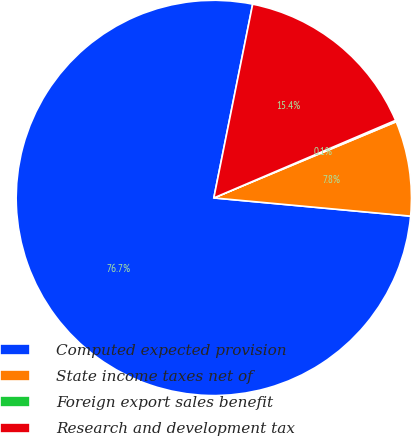<chart> <loc_0><loc_0><loc_500><loc_500><pie_chart><fcel>Computed expected provision<fcel>State income taxes net of<fcel>Foreign export sales benefit<fcel>Research and development tax<nl><fcel>76.68%<fcel>7.77%<fcel>0.12%<fcel>15.43%<nl></chart> 